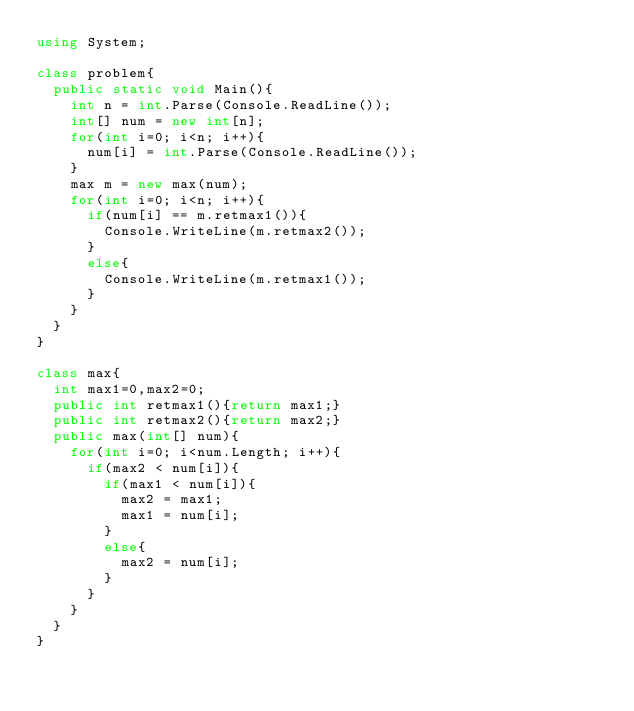Convert code to text. <code><loc_0><loc_0><loc_500><loc_500><_C#_>using System;

class problem{
  public static void Main(){
    int n = int.Parse(Console.ReadLine());
    int[] num = new int[n];
    for(int i=0; i<n; i++){
      num[i] = int.Parse(Console.ReadLine());
    }
    max m = new max(num);
    for(int i=0; i<n; i++){
      if(num[i] == m.retmax1()){
        Console.WriteLine(m.retmax2());
      }
      else{
        Console.WriteLine(m.retmax1());
      }
    }
  }
}

class max{
  int max1=0,max2=0;
  public int retmax1(){return max1;}
  public int retmax2(){return max2;}
  public max(int[] num){
    for(int i=0; i<num.Length; i++){
      if(max2 < num[i]){
        if(max1 < num[i]){
          max2 = max1;
          max1 = num[i];
        }
        else{
          max2 = num[i];
        }
      }
    }
  }
}
</code> 